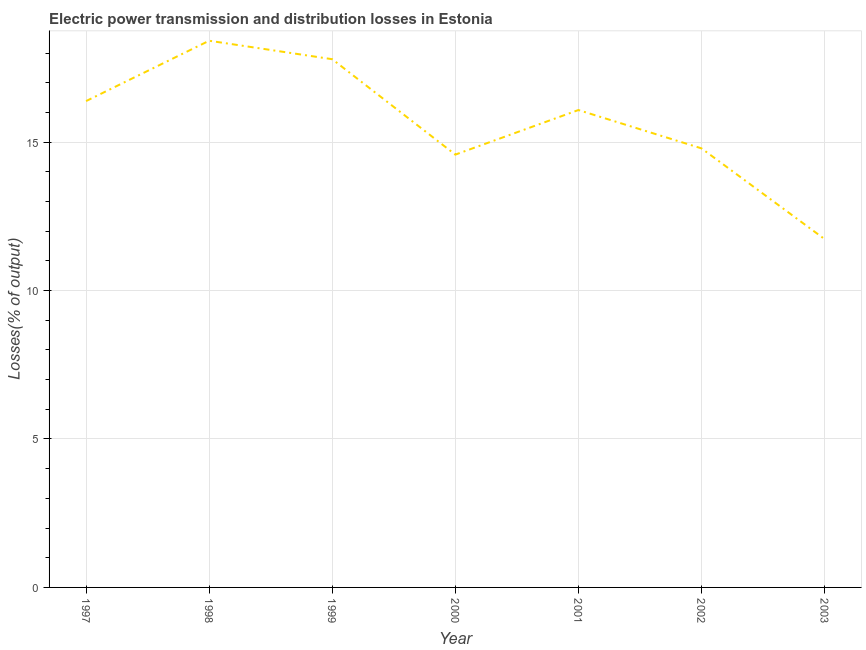What is the electric power transmission and distribution losses in 2000?
Offer a terse response. 14.58. Across all years, what is the maximum electric power transmission and distribution losses?
Your response must be concise. 18.41. Across all years, what is the minimum electric power transmission and distribution losses?
Offer a terse response. 11.73. In which year was the electric power transmission and distribution losses maximum?
Your answer should be very brief. 1998. In which year was the electric power transmission and distribution losses minimum?
Your answer should be very brief. 2003. What is the sum of the electric power transmission and distribution losses?
Your answer should be very brief. 109.76. What is the difference between the electric power transmission and distribution losses in 2000 and 2002?
Provide a succinct answer. -0.21. What is the average electric power transmission and distribution losses per year?
Provide a succinct answer. 15.68. What is the median electric power transmission and distribution losses?
Provide a succinct answer. 16.08. In how many years, is the electric power transmission and distribution losses greater than 16 %?
Keep it short and to the point. 4. What is the ratio of the electric power transmission and distribution losses in 2000 to that in 2003?
Your response must be concise. 1.24. Is the electric power transmission and distribution losses in 1998 less than that in 2000?
Provide a short and direct response. No. What is the difference between the highest and the second highest electric power transmission and distribution losses?
Give a very brief answer. 0.62. Is the sum of the electric power transmission and distribution losses in 1998 and 2001 greater than the maximum electric power transmission and distribution losses across all years?
Ensure brevity in your answer.  Yes. What is the difference between the highest and the lowest electric power transmission and distribution losses?
Offer a very short reply. 6.68. In how many years, is the electric power transmission and distribution losses greater than the average electric power transmission and distribution losses taken over all years?
Your answer should be very brief. 4. Does the electric power transmission and distribution losses monotonically increase over the years?
Your response must be concise. No. How many lines are there?
Provide a short and direct response. 1. What is the difference between two consecutive major ticks on the Y-axis?
Provide a succinct answer. 5. Does the graph contain any zero values?
Your answer should be very brief. No. Does the graph contain grids?
Provide a short and direct response. Yes. What is the title of the graph?
Provide a succinct answer. Electric power transmission and distribution losses in Estonia. What is the label or title of the X-axis?
Provide a succinct answer. Year. What is the label or title of the Y-axis?
Ensure brevity in your answer.  Losses(% of output). What is the Losses(% of output) of 1997?
Offer a very short reply. 16.38. What is the Losses(% of output) of 1998?
Offer a terse response. 18.41. What is the Losses(% of output) in 1999?
Provide a succinct answer. 17.79. What is the Losses(% of output) of 2000?
Ensure brevity in your answer.  14.58. What is the Losses(% of output) of 2001?
Provide a short and direct response. 16.08. What is the Losses(% of output) in 2002?
Make the answer very short. 14.79. What is the Losses(% of output) of 2003?
Make the answer very short. 11.73. What is the difference between the Losses(% of output) in 1997 and 1998?
Give a very brief answer. -2.03. What is the difference between the Losses(% of output) in 1997 and 1999?
Your answer should be compact. -1.41. What is the difference between the Losses(% of output) in 1997 and 2000?
Give a very brief answer. 1.8. What is the difference between the Losses(% of output) in 1997 and 2001?
Provide a short and direct response. 0.3. What is the difference between the Losses(% of output) in 1997 and 2002?
Keep it short and to the point. 1.59. What is the difference between the Losses(% of output) in 1997 and 2003?
Offer a terse response. 4.65. What is the difference between the Losses(% of output) in 1998 and 1999?
Your answer should be very brief. 0.62. What is the difference between the Losses(% of output) in 1998 and 2000?
Offer a terse response. 3.84. What is the difference between the Losses(% of output) in 1998 and 2001?
Provide a succinct answer. 2.33. What is the difference between the Losses(% of output) in 1998 and 2002?
Ensure brevity in your answer.  3.63. What is the difference between the Losses(% of output) in 1998 and 2003?
Make the answer very short. 6.68. What is the difference between the Losses(% of output) in 1999 and 2000?
Provide a succinct answer. 3.21. What is the difference between the Losses(% of output) in 1999 and 2001?
Provide a short and direct response. 1.71. What is the difference between the Losses(% of output) in 1999 and 2002?
Keep it short and to the point. 3. What is the difference between the Losses(% of output) in 1999 and 2003?
Make the answer very short. 6.06. What is the difference between the Losses(% of output) in 2000 and 2001?
Offer a very short reply. -1.5. What is the difference between the Losses(% of output) in 2000 and 2002?
Provide a short and direct response. -0.21. What is the difference between the Losses(% of output) in 2000 and 2003?
Ensure brevity in your answer.  2.84. What is the difference between the Losses(% of output) in 2001 and 2002?
Your answer should be compact. 1.29. What is the difference between the Losses(% of output) in 2001 and 2003?
Ensure brevity in your answer.  4.35. What is the difference between the Losses(% of output) in 2002 and 2003?
Offer a very short reply. 3.05. What is the ratio of the Losses(% of output) in 1997 to that in 1998?
Provide a succinct answer. 0.89. What is the ratio of the Losses(% of output) in 1997 to that in 1999?
Your response must be concise. 0.92. What is the ratio of the Losses(% of output) in 1997 to that in 2000?
Your answer should be compact. 1.12. What is the ratio of the Losses(% of output) in 1997 to that in 2002?
Your answer should be compact. 1.11. What is the ratio of the Losses(% of output) in 1997 to that in 2003?
Offer a terse response. 1.4. What is the ratio of the Losses(% of output) in 1998 to that in 1999?
Your answer should be compact. 1.03. What is the ratio of the Losses(% of output) in 1998 to that in 2000?
Offer a terse response. 1.26. What is the ratio of the Losses(% of output) in 1998 to that in 2001?
Ensure brevity in your answer.  1.15. What is the ratio of the Losses(% of output) in 1998 to that in 2002?
Your response must be concise. 1.25. What is the ratio of the Losses(% of output) in 1998 to that in 2003?
Keep it short and to the point. 1.57. What is the ratio of the Losses(% of output) in 1999 to that in 2000?
Your answer should be very brief. 1.22. What is the ratio of the Losses(% of output) in 1999 to that in 2001?
Provide a short and direct response. 1.11. What is the ratio of the Losses(% of output) in 1999 to that in 2002?
Keep it short and to the point. 1.2. What is the ratio of the Losses(% of output) in 1999 to that in 2003?
Make the answer very short. 1.52. What is the ratio of the Losses(% of output) in 2000 to that in 2001?
Offer a very short reply. 0.91. What is the ratio of the Losses(% of output) in 2000 to that in 2002?
Provide a short and direct response. 0.99. What is the ratio of the Losses(% of output) in 2000 to that in 2003?
Give a very brief answer. 1.24. What is the ratio of the Losses(% of output) in 2001 to that in 2002?
Your answer should be compact. 1.09. What is the ratio of the Losses(% of output) in 2001 to that in 2003?
Offer a very short reply. 1.37. What is the ratio of the Losses(% of output) in 2002 to that in 2003?
Your response must be concise. 1.26. 